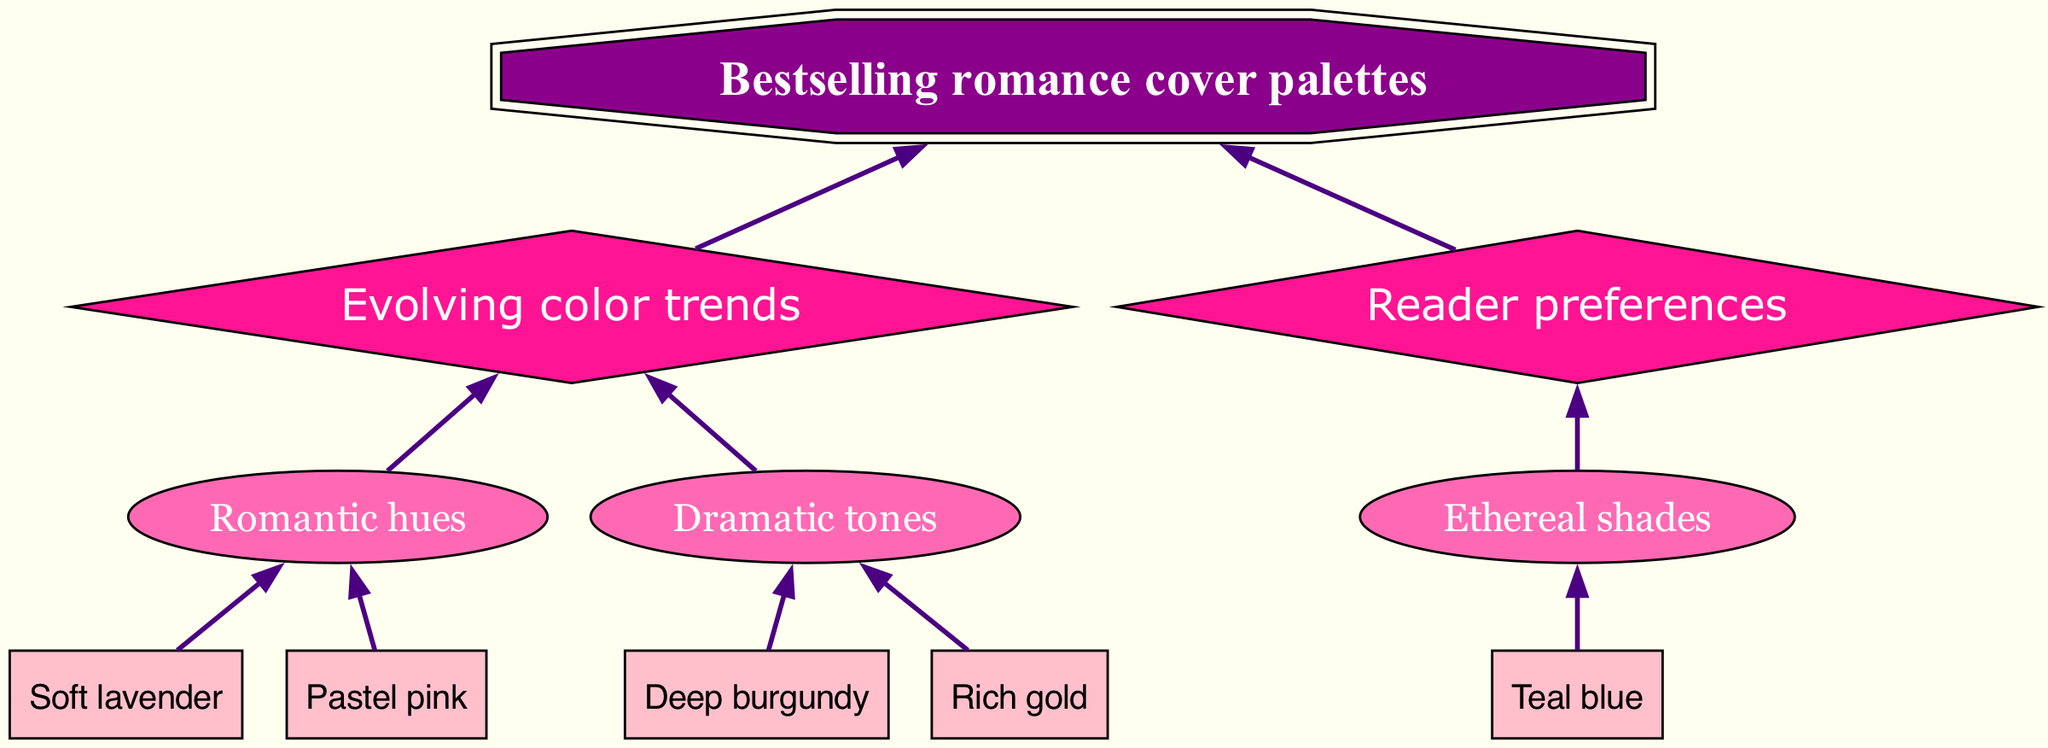What are the bottom elements in the diagram? The bottom elements are explicitly listed in the diagram, which are "Pastel pink," "Deep burgundy," "Soft lavender," "Rich gold," and "Teal blue."
Answer: Pastel pink, Deep burgundy, Soft lavender, Rich gold, Teal blue How many middle elements are there? The diagram shows that there are three middle elements: "Romantic hues," "Dramatic tones," and "Ethereal shades." Counting these gives a total of three.
Answer: 3 Which bottom element connects to "Dramatic tones"? There are two connections from the bottom to "Dramatic tones": one from "Deep burgundy" and another from "Rich gold."
Answer: Deep burgundy, Rich gold What is the final element in the flow chart? The final element is defined as "Bestselling romance cover palettes" and is represented prominently in the diagram, making it clear.
Answer: Bestselling romance cover palettes What connects "Romantic hues" to the top element? The connections show that "Romantic hues" connects to "Evolving color trends," which is one of the top elements in the diagram.
Answer: Evolving color trends Which bottom elements lead to "Romantic hues"? The bottom elements that connect to "Romantic hues" are "Pastel pink" and "Soft lavender," as indicated by their direct connections.
Answer: Pastel pink, Soft lavender Which top element is directly related to "Reader preferences"? The relationship indicates that "Reader preferences" connects to the final element. Since it’s a top element, we can see that it’s connected to "Bestselling romance cover palettes."
Answer: Reader preferences What do both "Evolving color trends" and "Reader preferences" share? Both "Evolving color trends" and "Reader preferences" are top elements and they both connect to the final element, "Bestselling romance cover palettes," indicating a shared relationship with the result.
Answer: Bestselling romance cover palettes How many edges are in the diagram? Counting the connections listed in the diagram, there are ten edges that connect various nodes together, showcasing relationships throughout the flow chart.
Answer: 10 